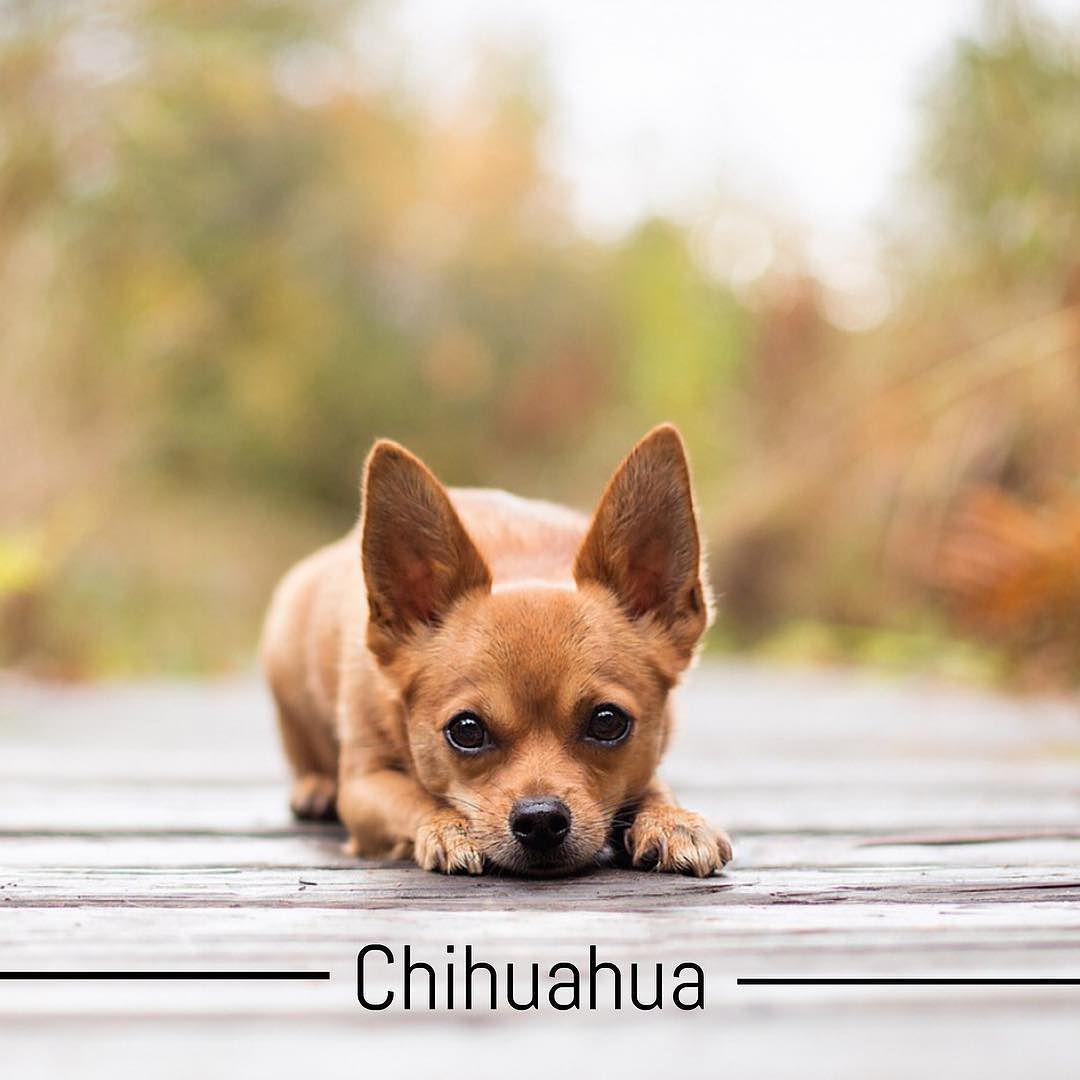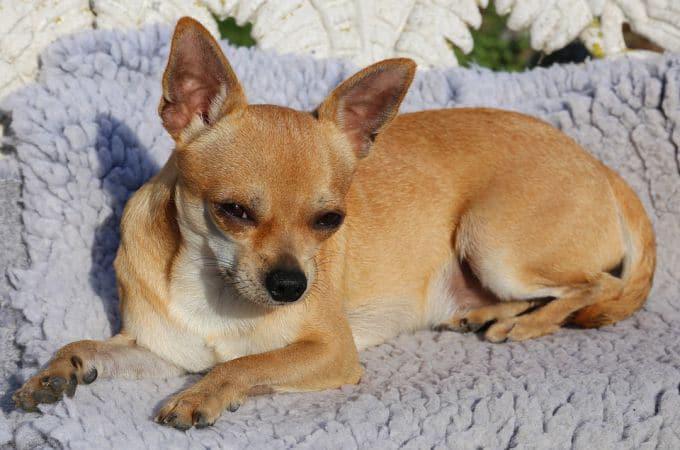The first image is the image on the left, the second image is the image on the right. Given the left and right images, does the statement "A cup with a handle is pictured with a tiny dog, in one image." hold true? Answer yes or no. No. The first image is the image on the left, the second image is the image on the right. Given the left and right images, does the statement "A cup is pictured with a chihuahua." hold true? Answer yes or no. No. 